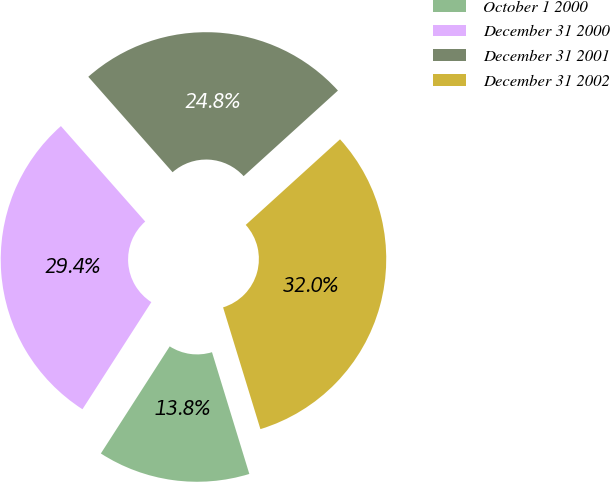Convert chart. <chart><loc_0><loc_0><loc_500><loc_500><pie_chart><fcel>October 1 2000<fcel>December 31 2000<fcel>December 31 2001<fcel>December 31 2002<nl><fcel>13.83%<fcel>29.39%<fcel>24.78%<fcel>31.99%<nl></chart> 